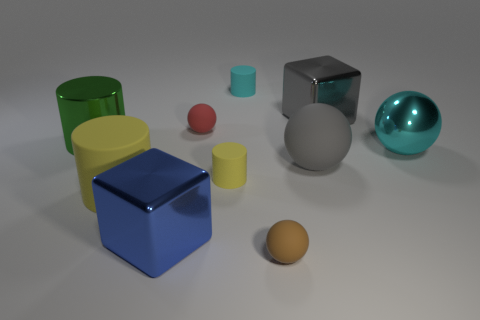There is a object that is the same color as the big rubber ball; what is its material?
Your response must be concise. Metal. There is a small object behind the red sphere; is it the same shape as the yellow matte thing in front of the tiny yellow matte thing?
Offer a terse response. Yes. There is a large gray block; what number of metal cylinders are behind it?
Give a very brief answer. 0. Are there any cyan cylinders made of the same material as the brown ball?
Your answer should be compact. Yes. There is another sphere that is the same size as the brown rubber ball; what is its material?
Provide a succinct answer. Rubber. Do the tiny yellow cylinder and the tiny cyan object have the same material?
Your answer should be very brief. Yes. What number of things are either big cyan metallic objects or balls?
Keep it short and to the point. 4. The metallic object that is behind the big green metallic object has what shape?
Offer a very short reply. Cube. What color is the other tiny cylinder that is the same material as the tiny yellow cylinder?
Your response must be concise. Cyan. What is the material of the blue object that is the same shape as the large gray shiny object?
Your answer should be very brief. Metal. 